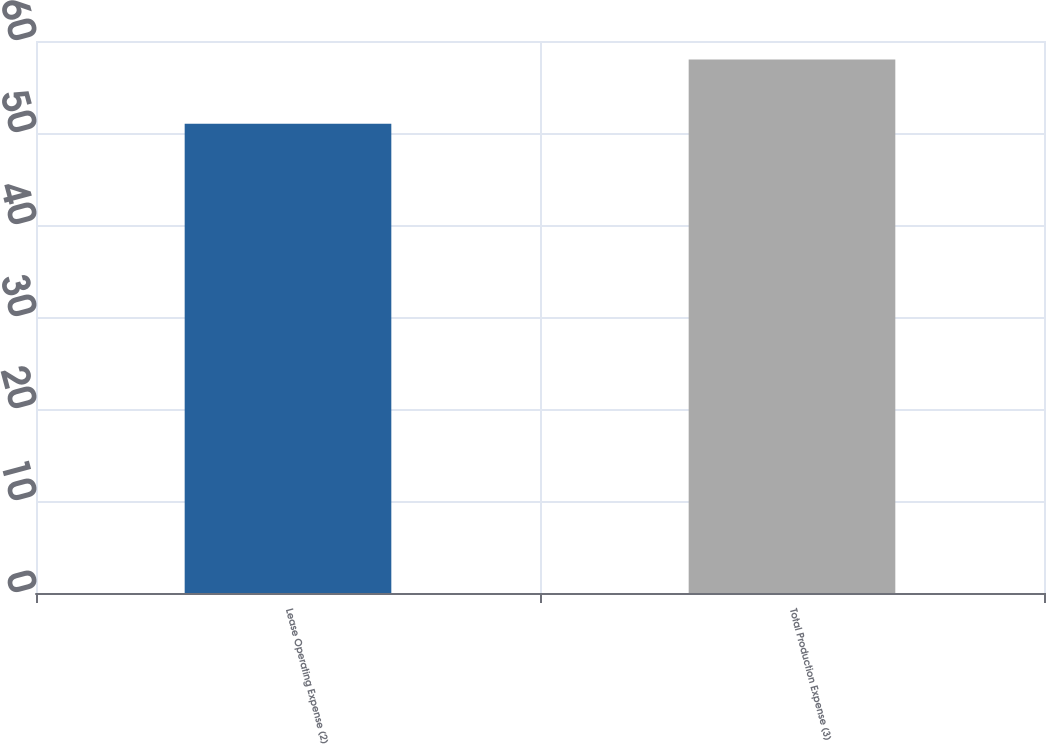Convert chart to OTSL. <chart><loc_0><loc_0><loc_500><loc_500><bar_chart><fcel>Lease Operating Expense (2)<fcel>Total Production Expense (3)<nl><fcel>51<fcel>58<nl></chart> 